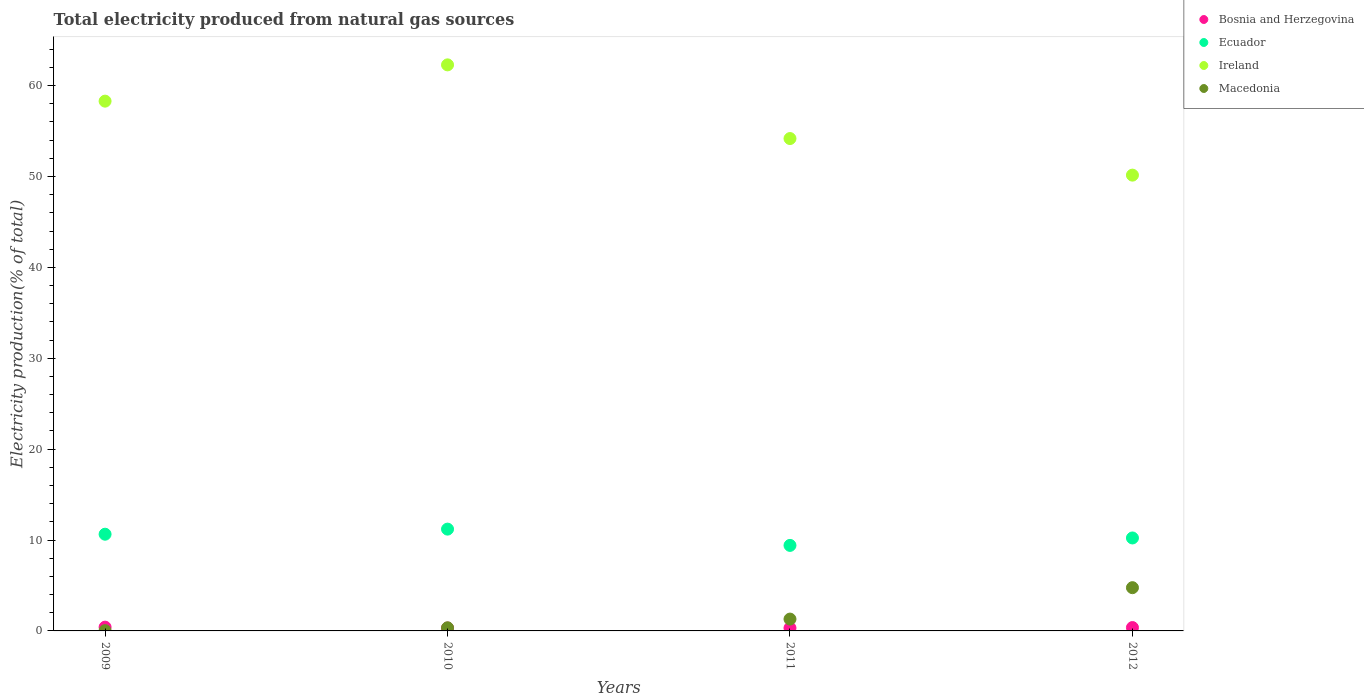What is the total electricity produced in Ireland in 2012?
Your answer should be compact. 50.15. Across all years, what is the maximum total electricity produced in Macedonia?
Keep it short and to the point. 4.76. Across all years, what is the minimum total electricity produced in Bosnia and Herzegovina?
Provide a short and direct response. 0.32. What is the total total electricity produced in Bosnia and Herzegovina in the graph?
Keep it short and to the point. 1.42. What is the difference between the total electricity produced in Macedonia in 2009 and that in 2011?
Provide a succinct answer. -1.27. What is the difference between the total electricity produced in Bosnia and Herzegovina in 2010 and the total electricity produced in Ireland in 2012?
Your response must be concise. -49.84. What is the average total electricity produced in Macedonia per year?
Your answer should be compact. 1.61. In the year 2011, what is the difference between the total electricity produced in Ecuador and total electricity produced in Ireland?
Keep it short and to the point. -44.77. What is the ratio of the total electricity produced in Ecuador in 2009 to that in 2010?
Your answer should be very brief. 0.95. Is the difference between the total electricity produced in Ecuador in 2010 and 2011 greater than the difference between the total electricity produced in Ireland in 2010 and 2011?
Offer a very short reply. No. What is the difference between the highest and the second highest total electricity produced in Bosnia and Herzegovina?
Your answer should be compact. 0.05. What is the difference between the highest and the lowest total electricity produced in Ecuador?
Your response must be concise. 1.79. Is the sum of the total electricity produced in Ecuador in 2009 and 2010 greater than the maximum total electricity produced in Bosnia and Herzegovina across all years?
Offer a very short reply. Yes. Is it the case that in every year, the sum of the total electricity produced in Macedonia and total electricity produced in Bosnia and Herzegovina  is greater than the total electricity produced in Ireland?
Your answer should be very brief. No. Does the total electricity produced in Ecuador monotonically increase over the years?
Make the answer very short. No. How many dotlines are there?
Make the answer very short. 4. How many years are there in the graph?
Your answer should be very brief. 4. Are the values on the major ticks of Y-axis written in scientific E-notation?
Make the answer very short. No. Does the graph contain any zero values?
Keep it short and to the point. No. How are the legend labels stacked?
Ensure brevity in your answer.  Vertical. What is the title of the graph?
Provide a succinct answer. Total electricity produced from natural gas sources. What is the label or title of the Y-axis?
Offer a terse response. Electricity production(% of total). What is the Electricity production(% of total) of Bosnia and Herzegovina in 2009?
Give a very brief answer. 0.41. What is the Electricity production(% of total) in Ecuador in 2009?
Your answer should be compact. 10.64. What is the Electricity production(% of total) in Ireland in 2009?
Provide a succinct answer. 58.29. What is the Electricity production(% of total) of Macedonia in 2009?
Provide a short and direct response. 0.03. What is the Electricity production(% of total) in Bosnia and Herzegovina in 2010?
Make the answer very short. 0.32. What is the Electricity production(% of total) of Ecuador in 2010?
Your response must be concise. 11.2. What is the Electricity production(% of total) in Ireland in 2010?
Keep it short and to the point. 62.29. What is the Electricity production(% of total) in Macedonia in 2010?
Your answer should be compact. 0.34. What is the Electricity production(% of total) of Bosnia and Herzegovina in 2011?
Make the answer very short. 0.32. What is the Electricity production(% of total) of Ecuador in 2011?
Give a very brief answer. 9.41. What is the Electricity production(% of total) of Ireland in 2011?
Offer a very short reply. 54.18. What is the Electricity production(% of total) of Macedonia in 2011?
Your answer should be compact. 1.3. What is the Electricity production(% of total) of Bosnia and Herzegovina in 2012?
Provide a short and direct response. 0.37. What is the Electricity production(% of total) of Ecuador in 2012?
Offer a very short reply. 10.23. What is the Electricity production(% of total) of Ireland in 2012?
Your response must be concise. 50.15. What is the Electricity production(% of total) of Macedonia in 2012?
Offer a terse response. 4.76. Across all years, what is the maximum Electricity production(% of total) in Bosnia and Herzegovina?
Provide a short and direct response. 0.41. Across all years, what is the maximum Electricity production(% of total) in Ecuador?
Offer a terse response. 11.2. Across all years, what is the maximum Electricity production(% of total) in Ireland?
Offer a very short reply. 62.29. Across all years, what is the maximum Electricity production(% of total) in Macedonia?
Make the answer very short. 4.76. Across all years, what is the minimum Electricity production(% of total) in Bosnia and Herzegovina?
Provide a short and direct response. 0.32. Across all years, what is the minimum Electricity production(% of total) of Ecuador?
Your response must be concise. 9.41. Across all years, what is the minimum Electricity production(% of total) in Ireland?
Ensure brevity in your answer.  50.15. Across all years, what is the minimum Electricity production(% of total) in Macedonia?
Give a very brief answer. 0.03. What is the total Electricity production(% of total) in Bosnia and Herzegovina in the graph?
Your answer should be very brief. 1.42. What is the total Electricity production(% of total) in Ecuador in the graph?
Offer a very short reply. 41.48. What is the total Electricity production(% of total) in Ireland in the graph?
Offer a very short reply. 224.91. What is the total Electricity production(% of total) of Macedonia in the graph?
Your answer should be compact. 6.43. What is the difference between the Electricity production(% of total) of Bosnia and Herzegovina in 2009 and that in 2010?
Your answer should be compact. 0.1. What is the difference between the Electricity production(% of total) of Ecuador in 2009 and that in 2010?
Your response must be concise. -0.56. What is the difference between the Electricity production(% of total) of Ireland in 2009 and that in 2010?
Provide a succinct answer. -3.99. What is the difference between the Electricity production(% of total) of Macedonia in 2009 and that in 2010?
Your answer should be very brief. -0.32. What is the difference between the Electricity production(% of total) in Bosnia and Herzegovina in 2009 and that in 2011?
Make the answer very short. 0.09. What is the difference between the Electricity production(% of total) in Ecuador in 2009 and that in 2011?
Offer a terse response. 1.23. What is the difference between the Electricity production(% of total) of Ireland in 2009 and that in 2011?
Provide a short and direct response. 4.12. What is the difference between the Electricity production(% of total) in Macedonia in 2009 and that in 2011?
Provide a short and direct response. -1.27. What is the difference between the Electricity production(% of total) in Bosnia and Herzegovina in 2009 and that in 2012?
Your answer should be compact. 0.05. What is the difference between the Electricity production(% of total) of Ecuador in 2009 and that in 2012?
Keep it short and to the point. 0.41. What is the difference between the Electricity production(% of total) of Ireland in 2009 and that in 2012?
Keep it short and to the point. 8.14. What is the difference between the Electricity production(% of total) of Macedonia in 2009 and that in 2012?
Provide a succinct answer. -4.73. What is the difference between the Electricity production(% of total) of Bosnia and Herzegovina in 2010 and that in 2011?
Your answer should be very brief. -0.01. What is the difference between the Electricity production(% of total) in Ecuador in 2010 and that in 2011?
Keep it short and to the point. 1.79. What is the difference between the Electricity production(% of total) in Ireland in 2010 and that in 2011?
Provide a succinct answer. 8.11. What is the difference between the Electricity production(% of total) of Macedonia in 2010 and that in 2011?
Your response must be concise. -0.96. What is the difference between the Electricity production(% of total) in Bosnia and Herzegovina in 2010 and that in 2012?
Offer a terse response. -0.05. What is the difference between the Electricity production(% of total) in Ecuador in 2010 and that in 2012?
Provide a short and direct response. 0.97. What is the difference between the Electricity production(% of total) of Ireland in 2010 and that in 2012?
Give a very brief answer. 12.13. What is the difference between the Electricity production(% of total) in Macedonia in 2010 and that in 2012?
Offer a very short reply. -4.41. What is the difference between the Electricity production(% of total) of Bosnia and Herzegovina in 2011 and that in 2012?
Offer a terse response. -0.05. What is the difference between the Electricity production(% of total) of Ecuador in 2011 and that in 2012?
Ensure brevity in your answer.  -0.82. What is the difference between the Electricity production(% of total) of Ireland in 2011 and that in 2012?
Offer a terse response. 4.03. What is the difference between the Electricity production(% of total) in Macedonia in 2011 and that in 2012?
Offer a very short reply. -3.46. What is the difference between the Electricity production(% of total) in Bosnia and Herzegovina in 2009 and the Electricity production(% of total) in Ecuador in 2010?
Provide a short and direct response. -10.79. What is the difference between the Electricity production(% of total) of Bosnia and Herzegovina in 2009 and the Electricity production(% of total) of Ireland in 2010?
Provide a succinct answer. -61.87. What is the difference between the Electricity production(% of total) in Bosnia and Herzegovina in 2009 and the Electricity production(% of total) in Macedonia in 2010?
Give a very brief answer. 0.07. What is the difference between the Electricity production(% of total) in Ecuador in 2009 and the Electricity production(% of total) in Ireland in 2010?
Make the answer very short. -51.65. What is the difference between the Electricity production(% of total) of Ecuador in 2009 and the Electricity production(% of total) of Macedonia in 2010?
Ensure brevity in your answer.  10.3. What is the difference between the Electricity production(% of total) of Ireland in 2009 and the Electricity production(% of total) of Macedonia in 2010?
Provide a short and direct response. 57.95. What is the difference between the Electricity production(% of total) of Bosnia and Herzegovina in 2009 and the Electricity production(% of total) of Ecuador in 2011?
Keep it short and to the point. -9. What is the difference between the Electricity production(% of total) in Bosnia and Herzegovina in 2009 and the Electricity production(% of total) in Ireland in 2011?
Ensure brevity in your answer.  -53.76. What is the difference between the Electricity production(% of total) of Bosnia and Herzegovina in 2009 and the Electricity production(% of total) of Macedonia in 2011?
Offer a terse response. -0.89. What is the difference between the Electricity production(% of total) of Ecuador in 2009 and the Electricity production(% of total) of Ireland in 2011?
Keep it short and to the point. -43.54. What is the difference between the Electricity production(% of total) in Ecuador in 2009 and the Electricity production(% of total) in Macedonia in 2011?
Keep it short and to the point. 9.34. What is the difference between the Electricity production(% of total) in Ireland in 2009 and the Electricity production(% of total) in Macedonia in 2011?
Your response must be concise. 56.99. What is the difference between the Electricity production(% of total) of Bosnia and Herzegovina in 2009 and the Electricity production(% of total) of Ecuador in 2012?
Offer a terse response. -9.81. What is the difference between the Electricity production(% of total) of Bosnia and Herzegovina in 2009 and the Electricity production(% of total) of Ireland in 2012?
Offer a very short reply. -49.74. What is the difference between the Electricity production(% of total) of Bosnia and Herzegovina in 2009 and the Electricity production(% of total) of Macedonia in 2012?
Give a very brief answer. -4.34. What is the difference between the Electricity production(% of total) of Ecuador in 2009 and the Electricity production(% of total) of Ireland in 2012?
Keep it short and to the point. -39.51. What is the difference between the Electricity production(% of total) of Ecuador in 2009 and the Electricity production(% of total) of Macedonia in 2012?
Make the answer very short. 5.88. What is the difference between the Electricity production(% of total) in Ireland in 2009 and the Electricity production(% of total) in Macedonia in 2012?
Give a very brief answer. 53.54. What is the difference between the Electricity production(% of total) of Bosnia and Herzegovina in 2010 and the Electricity production(% of total) of Ecuador in 2011?
Offer a very short reply. -9.1. What is the difference between the Electricity production(% of total) in Bosnia and Herzegovina in 2010 and the Electricity production(% of total) in Ireland in 2011?
Offer a very short reply. -53.86. What is the difference between the Electricity production(% of total) in Bosnia and Herzegovina in 2010 and the Electricity production(% of total) in Macedonia in 2011?
Your answer should be compact. -0.99. What is the difference between the Electricity production(% of total) in Ecuador in 2010 and the Electricity production(% of total) in Ireland in 2011?
Make the answer very short. -42.98. What is the difference between the Electricity production(% of total) in Ecuador in 2010 and the Electricity production(% of total) in Macedonia in 2011?
Keep it short and to the point. 9.9. What is the difference between the Electricity production(% of total) of Ireland in 2010 and the Electricity production(% of total) of Macedonia in 2011?
Give a very brief answer. 60.98. What is the difference between the Electricity production(% of total) in Bosnia and Herzegovina in 2010 and the Electricity production(% of total) in Ecuador in 2012?
Offer a very short reply. -9.91. What is the difference between the Electricity production(% of total) of Bosnia and Herzegovina in 2010 and the Electricity production(% of total) of Ireland in 2012?
Provide a succinct answer. -49.84. What is the difference between the Electricity production(% of total) of Bosnia and Herzegovina in 2010 and the Electricity production(% of total) of Macedonia in 2012?
Offer a very short reply. -4.44. What is the difference between the Electricity production(% of total) in Ecuador in 2010 and the Electricity production(% of total) in Ireland in 2012?
Provide a succinct answer. -38.95. What is the difference between the Electricity production(% of total) in Ecuador in 2010 and the Electricity production(% of total) in Macedonia in 2012?
Offer a very short reply. 6.44. What is the difference between the Electricity production(% of total) in Ireland in 2010 and the Electricity production(% of total) in Macedonia in 2012?
Keep it short and to the point. 57.53. What is the difference between the Electricity production(% of total) of Bosnia and Herzegovina in 2011 and the Electricity production(% of total) of Ecuador in 2012?
Provide a short and direct response. -9.91. What is the difference between the Electricity production(% of total) in Bosnia and Herzegovina in 2011 and the Electricity production(% of total) in Ireland in 2012?
Ensure brevity in your answer.  -49.83. What is the difference between the Electricity production(% of total) of Bosnia and Herzegovina in 2011 and the Electricity production(% of total) of Macedonia in 2012?
Keep it short and to the point. -4.44. What is the difference between the Electricity production(% of total) in Ecuador in 2011 and the Electricity production(% of total) in Ireland in 2012?
Offer a very short reply. -40.74. What is the difference between the Electricity production(% of total) of Ecuador in 2011 and the Electricity production(% of total) of Macedonia in 2012?
Provide a short and direct response. 4.65. What is the difference between the Electricity production(% of total) in Ireland in 2011 and the Electricity production(% of total) in Macedonia in 2012?
Your answer should be compact. 49.42. What is the average Electricity production(% of total) of Bosnia and Herzegovina per year?
Offer a terse response. 0.35. What is the average Electricity production(% of total) in Ecuador per year?
Make the answer very short. 10.37. What is the average Electricity production(% of total) in Ireland per year?
Offer a terse response. 56.23. What is the average Electricity production(% of total) in Macedonia per year?
Offer a very short reply. 1.61. In the year 2009, what is the difference between the Electricity production(% of total) in Bosnia and Herzegovina and Electricity production(% of total) in Ecuador?
Ensure brevity in your answer.  -10.23. In the year 2009, what is the difference between the Electricity production(% of total) in Bosnia and Herzegovina and Electricity production(% of total) in Ireland?
Offer a very short reply. -57.88. In the year 2009, what is the difference between the Electricity production(% of total) of Bosnia and Herzegovina and Electricity production(% of total) of Macedonia?
Give a very brief answer. 0.39. In the year 2009, what is the difference between the Electricity production(% of total) in Ecuador and Electricity production(% of total) in Ireland?
Offer a terse response. -47.65. In the year 2009, what is the difference between the Electricity production(% of total) of Ecuador and Electricity production(% of total) of Macedonia?
Your response must be concise. 10.61. In the year 2009, what is the difference between the Electricity production(% of total) in Ireland and Electricity production(% of total) in Macedonia?
Keep it short and to the point. 58.27. In the year 2010, what is the difference between the Electricity production(% of total) of Bosnia and Herzegovina and Electricity production(% of total) of Ecuador?
Keep it short and to the point. -10.89. In the year 2010, what is the difference between the Electricity production(% of total) of Bosnia and Herzegovina and Electricity production(% of total) of Ireland?
Ensure brevity in your answer.  -61.97. In the year 2010, what is the difference between the Electricity production(% of total) of Bosnia and Herzegovina and Electricity production(% of total) of Macedonia?
Your answer should be very brief. -0.03. In the year 2010, what is the difference between the Electricity production(% of total) of Ecuador and Electricity production(% of total) of Ireland?
Your answer should be very brief. -51.09. In the year 2010, what is the difference between the Electricity production(% of total) in Ecuador and Electricity production(% of total) in Macedonia?
Make the answer very short. 10.86. In the year 2010, what is the difference between the Electricity production(% of total) of Ireland and Electricity production(% of total) of Macedonia?
Offer a very short reply. 61.94. In the year 2011, what is the difference between the Electricity production(% of total) of Bosnia and Herzegovina and Electricity production(% of total) of Ecuador?
Your response must be concise. -9.09. In the year 2011, what is the difference between the Electricity production(% of total) in Bosnia and Herzegovina and Electricity production(% of total) in Ireland?
Keep it short and to the point. -53.86. In the year 2011, what is the difference between the Electricity production(% of total) in Bosnia and Herzegovina and Electricity production(% of total) in Macedonia?
Your answer should be compact. -0.98. In the year 2011, what is the difference between the Electricity production(% of total) in Ecuador and Electricity production(% of total) in Ireland?
Give a very brief answer. -44.77. In the year 2011, what is the difference between the Electricity production(% of total) of Ecuador and Electricity production(% of total) of Macedonia?
Offer a terse response. 8.11. In the year 2011, what is the difference between the Electricity production(% of total) of Ireland and Electricity production(% of total) of Macedonia?
Provide a short and direct response. 52.88. In the year 2012, what is the difference between the Electricity production(% of total) of Bosnia and Herzegovina and Electricity production(% of total) of Ecuador?
Offer a terse response. -9.86. In the year 2012, what is the difference between the Electricity production(% of total) in Bosnia and Herzegovina and Electricity production(% of total) in Ireland?
Your answer should be very brief. -49.78. In the year 2012, what is the difference between the Electricity production(% of total) of Bosnia and Herzegovina and Electricity production(% of total) of Macedonia?
Provide a short and direct response. -4.39. In the year 2012, what is the difference between the Electricity production(% of total) in Ecuador and Electricity production(% of total) in Ireland?
Your answer should be very brief. -39.92. In the year 2012, what is the difference between the Electricity production(% of total) of Ecuador and Electricity production(% of total) of Macedonia?
Make the answer very short. 5.47. In the year 2012, what is the difference between the Electricity production(% of total) in Ireland and Electricity production(% of total) in Macedonia?
Your answer should be compact. 45.39. What is the ratio of the Electricity production(% of total) in Bosnia and Herzegovina in 2009 to that in 2010?
Offer a very short reply. 1.32. What is the ratio of the Electricity production(% of total) in Ireland in 2009 to that in 2010?
Your answer should be compact. 0.94. What is the ratio of the Electricity production(% of total) of Macedonia in 2009 to that in 2010?
Provide a short and direct response. 0.09. What is the ratio of the Electricity production(% of total) of Bosnia and Herzegovina in 2009 to that in 2011?
Ensure brevity in your answer.  1.29. What is the ratio of the Electricity production(% of total) of Ecuador in 2009 to that in 2011?
Keep it short and to the point. 1.13. What is the ratio of the Electricity production(% of total) in Ireland in 2009 to that in 2011?
Provide a succinct answer. 1.08. What is the ratio of the Electricity production(% of total) of Macedonia in 2009 to that in 2011?
Your answer should be very brief. 0.02. What is the ratio of the Electricity production(% of total) in Bosnia and Herzegovina in 2009 to that in 2012?
Your answer should be compact. 1.12. What is the ratio of the Electricity production(% of total) of Ecuador in 2009 to that in 2012?
Your answer should be compact. 1.04. What is the ratio of the Electricity production(% of total) in Ireland in 2009 to that in 2012?
Your answer should be very brief. 1.16. What is the ratio of the Electricity production(% of total) in Macedonia in 2009 to that in 2012?
Ensure brevity in your answer.  0.01. What is the ratio of the Electricity production(% of total) of Bosnia and Herzegovina in 2010 to that in 2011?
Make the answer very short. 0.98. What is the ratio of the Electricity production(% of total) in Ecuador in 2010 to that in 2011?
Your response must be concise. 1.19. What is the ratio of the Electricity production(% of total) in Ireland in 2010 to that in 2011?
Your answer should be very brief. 1.15. What is the ratio of the Electricity production(% of total) in Macedonia in 2010 to that in 2011?
Your answer should be very brief. 0.26. What is the ratio of the Electricity production(% of total) in Bosnia and Herzegovina in 2010 to that in 2012?
Provide a succinct answer. 0.85. What is the ratio of the Electricity production(% of total) in Ecuador in 2010 to that in 2012?
Offer a terse response. 1.1. What is the ratio of the Electricity production(% of total) in Ireland in 2010 to that in 2012?
Ensure brevity in your answer.  1.24. What is the ratio of the Electricity production(% of total) in Macedonia in 2010 to that in 2012?
Provide a succinct answer. 0.07. What is the ratio of the Electricity production(% of total) in Bosnia and Herzegovina in 2011 to that in 2012?
Provide a succinct answer. 0.87. What is the ratio of the Electricity production(% of total) of Ecuador in 2011 to that in 2012?
Offer a terse response. 0.92. What is the ratio of the Electricity production(% of total) of Ireland in 2011 to that in 2012?
Your answer should be very brief. 1.08. What is the ratio of the Electricity production(% of total) in Macedonia in 2011 to that in 2012?
Make the answer very short. 0.27. What is the difference between the highest and the second highest Electricity production(% of total) of Bosnia and Herzegovina?
Provide a succinct answer. 0.05. What is the difference between the highest and the second highest Electricity production(% of total) in Ecuador?
Make the answer very short. 0.56. What is the difference between the highest and the second highest Electricity production(% of total) of Ireland?
Keep it short and to the point. 3.99. What is the difference between the highest and the second highest Electricity production(% of total) of Macedonia?
Offer a terse response. 3.46. What is the difference between the highest and the lowest Electricity production(% of total) of Bosnia and Herzegovina?
Your answer should be very brief. 0.1. What is the difference between the highest and the lowest Electricity production(% of total) in Ecuador?
Ensure brevity in your answer.  1.79. What is the difference between the highest and the lowest Electricity production(% of total) of Ireland?
Your answer should be compact. 12.13. What is the difference between the highest and the lowest Electricity production(% of total) in Macedonia?
Your answer should be very brief. 4.73. 